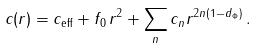<formula> <loc_0><loc_0><loc_500><loc_500>c ( r ) = c _ { \text {eff} } + f _ { 0 } \, r ^ { 2 } + \sum _ { n } c _ { n } r ^ { 2 n ( 1 - d _ { \Phi } ) } \, .</formula> 